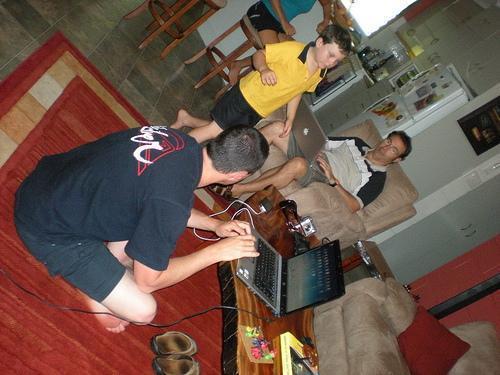What company made the silver laptop the man on the couch is using?
Choose the right answer and clarify with the format: 'Answer: answer
Rationale: rationale.'
Options: Microsoft, apple, hp, dell. Answer: apple.
Rationale: You can see the logo on the back of the computer. 